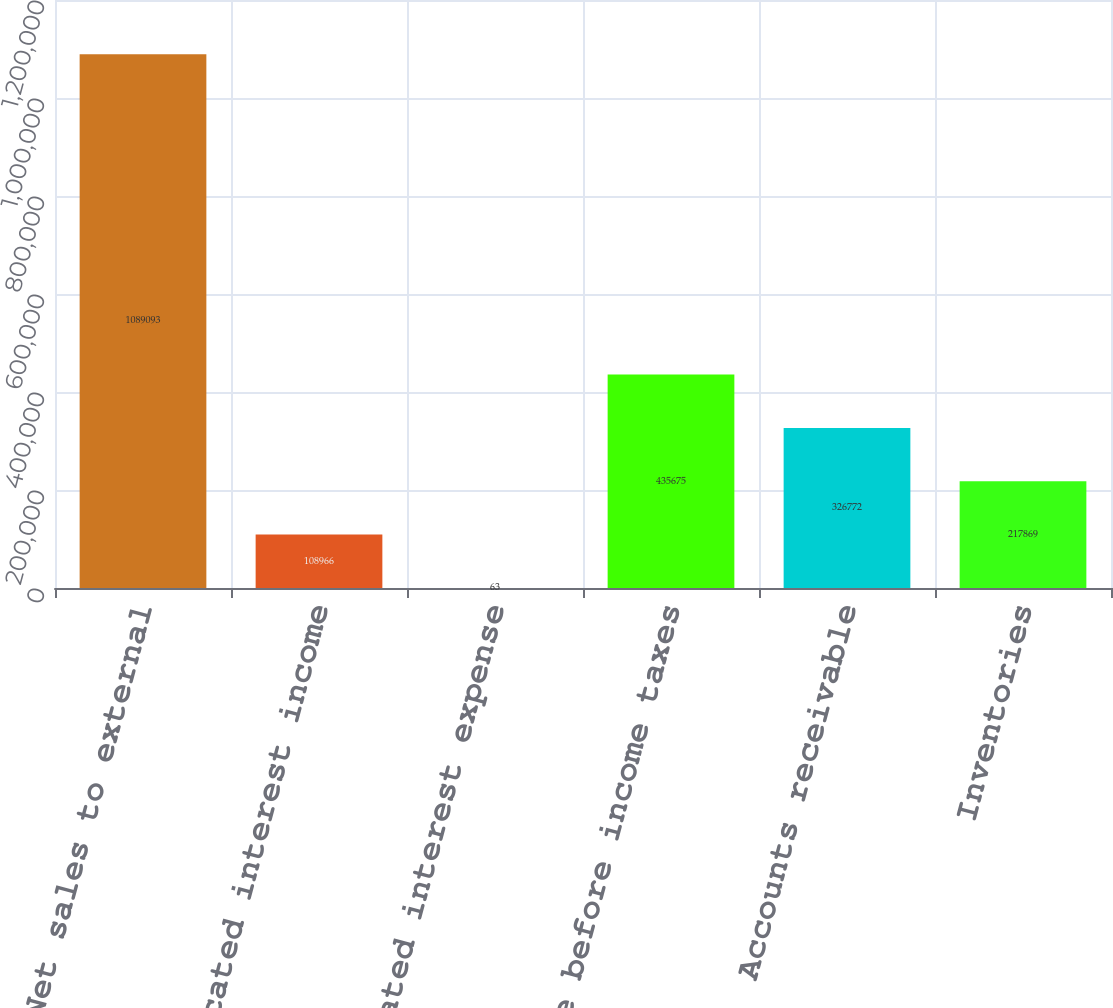Convert chart to OTSL. <chart><loc_0><loc_0><loc_500><loc_500><bar_chart><fcel>Net sales to external<fcel>Allocated interest income<fcel>Allocated interest expense<fcel>Income before income taxes<fcel>Accounts receivable<fcel>Inventories<nl><fcel>1.08909e+06<fcel>108966<fcel>63<fcel>435675<fcel>326772<fcel>217869<nl></chart> 